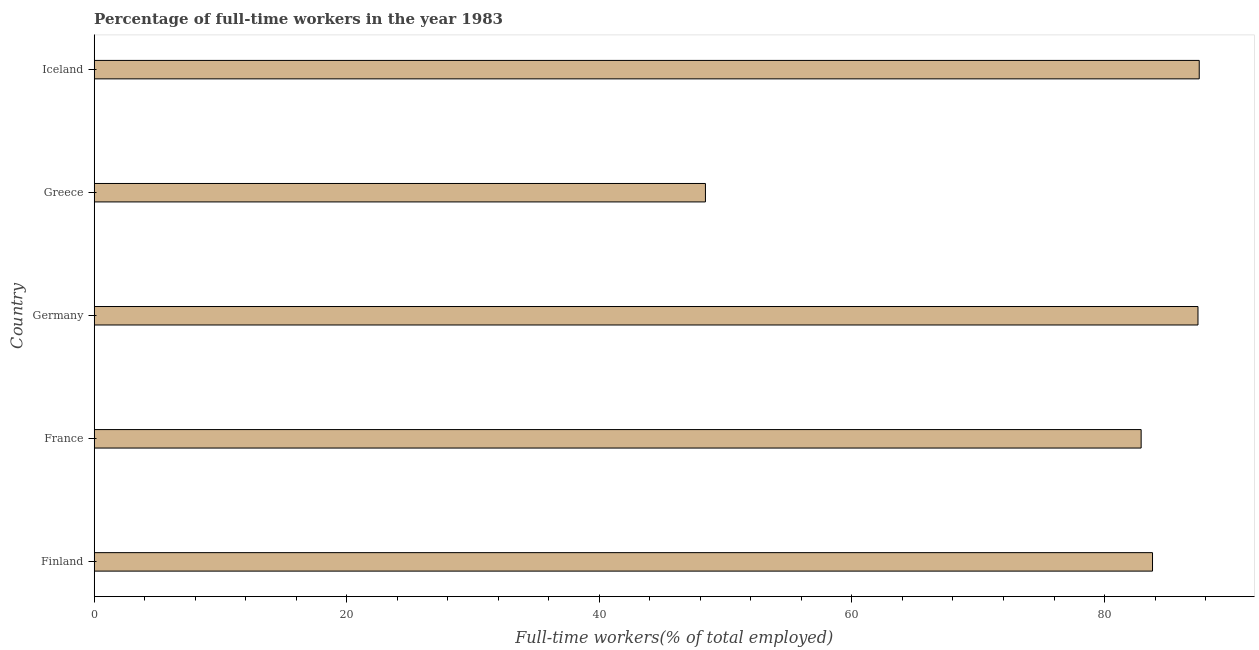Does the graph contain any zero values?
Your response must be concise. No. What is the title of the graph?
Ensure brevity in your answer.  Percentage of full-time workers in the year 1983. What is the label or title of the X-axis?
Provide a succinct answer. Full-time workers(% of total employed). What is the label or title of the Y-axis?
Your answer should be very brief. Country. What is the percentage of full-time workers in Finland?
Your answer should be very brief. 83.8. Across all countries, what is the maximum percentage of full-time workers?
Keep it short and to the point. 87.5. Across all countries, what is the minimum percentage of full-time workers?
Offer a terse response. 48.4. In which country was the percentage of full-time workers maximum?
Your answer should be very brief. Iceland. What is the sum of the percentage of full-time workers?
Your answer should be very brief. 390. What is the difference between the percentage of full-time workers in Greece and Iceland?
Offer a very short reply. -39.1. What is the median percentage of full-time workers?
Make the answer very short. 83.8. In how many countries, is the percentage of full-time workers greater than 24 %?
Ensure brevity in your answer.  5. What is the ratio of the percentage of full-time workers in France to that in Germany?
Provide a succinct answer. 0.95. Is the difference between the percentage of full-time workers in Germany and Iceland greater than the difference between any two countries?
Ensure brevity in your answer.  No. What is the difference between the highest and the second highest percentage of full-time workers?
Keep it short and to the point. 0.1. What is the difference between the highest and the lowest percentage of full-time workers?
Ensure brevity in your answer.  39.1. How many bars are there?
Provide a succinct answer. 5. What is the difference between two consecutive major ticks on the X-axis?
Your response must be concise. 20. What is the Full-time workers(% of total employed) in Finland?
Provide a succinct answer. 83.8. What is the Full-time workers(% of total employed) in France?
Give a very brief answer. 82.9. What is the Full-time workers(% of total employed) in Germany?
Your response must be concise. 87.4. What is the Full-time workers(% of total employed) in Greece?
Ensure brevity in your answer.  48.4. What is the Full-time workers(% of total employed) of Iceland?
Provide a short and direct response. 87.5. What is the difference between the Full-time workers(% of total employed) in Finland and France?
Provide a short and direct response. 0.9. What is the difference between the Full-time workers(% of total employed) in Finland and Greece?
Your answer should be very brief. 35.4. What is the difference between the Full-time workers(% of total employed) in Finland and Iceland?
Your response must be concise. -3.7. What is the difference between the Full-time workers(% of total employed) in France and Greece?
Your answer should be very brief. 34.5. What is the difference between the Full-time workers(% of total employed) in Greece and Iceland?
Make the answer very short. -39.1. What is the ratio of the Full-time workers(% of total employed) in Finland to that in Greece?
Provide a succinct answer. 1.73. What is the ratio of the Full-time workers(% of total employed) in Finland to that in Iceland?
Ensure brevity in your answer.  0.96. What is the ratio of the Full-time workers(% of total employed) in France to that in Germany?
Ensure brevity in your answer.  0.95. What is the ratio of the Full-time workers(% of total employed) in France to that in Greece?
Your answer should be very brief. 1.71. What is the ratio of the Full-time workers(% of total employed) in France to that in Iceland?
Your answer should be very brief. 0.95. What is the ratio of the Full-time workers(% of total employed) in Germany to that in Greece?
Provide a succinct answer. 1.81. What is the ratio of the Full-time workers(% of total employed) in Greece to that in Iceland?
Your answer should be very brief. 0.55. 